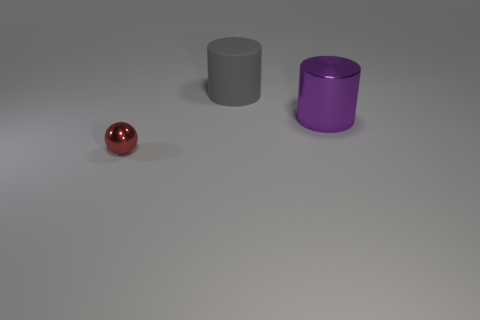There is a gray thing; does it have the same size as the metallic thing that is behind the red object?
Provide a short and direct response. Yes. Are there any purple objects behind the metal object behind the tiny metallic thing?
Your response must be concise. No. Is there a cyan matte object of the same shape as the purple thing?
Your answer should be very brief. No. What number of gray cylinders are to the right of the big cylinder on the left side of the purple shiny cylinder that is to the right of the large gray rubber thing?
Make the answer very short. 0. There is a big matte object; is it the same color as the metal thing that is behind the tiny shiny object?
Make the answer very short. No. How many things are objects to the right of the large matte thing or objects that are left of the purple cylinder?
Your answer should be very brief. 3. Is the number of metallic balls on the left side of the small red object greater than the number of rubber things in front of the large purple thing?
Your answer should be compact. No. There is a large cylinder that is in front of the cylinder that is behind the purple metal object that is in front of the gray cylinder; what is it made of?
Provide a short and direct response. Metal. Is the shape of the metal thing on the left side of the large purple shiny thing the same as the large purple metal object right of the rubber thing?
Your answer should be very brief. No. Is there a matte object of the same size as the gray cylinder?
Provide a short and direct response. No. 